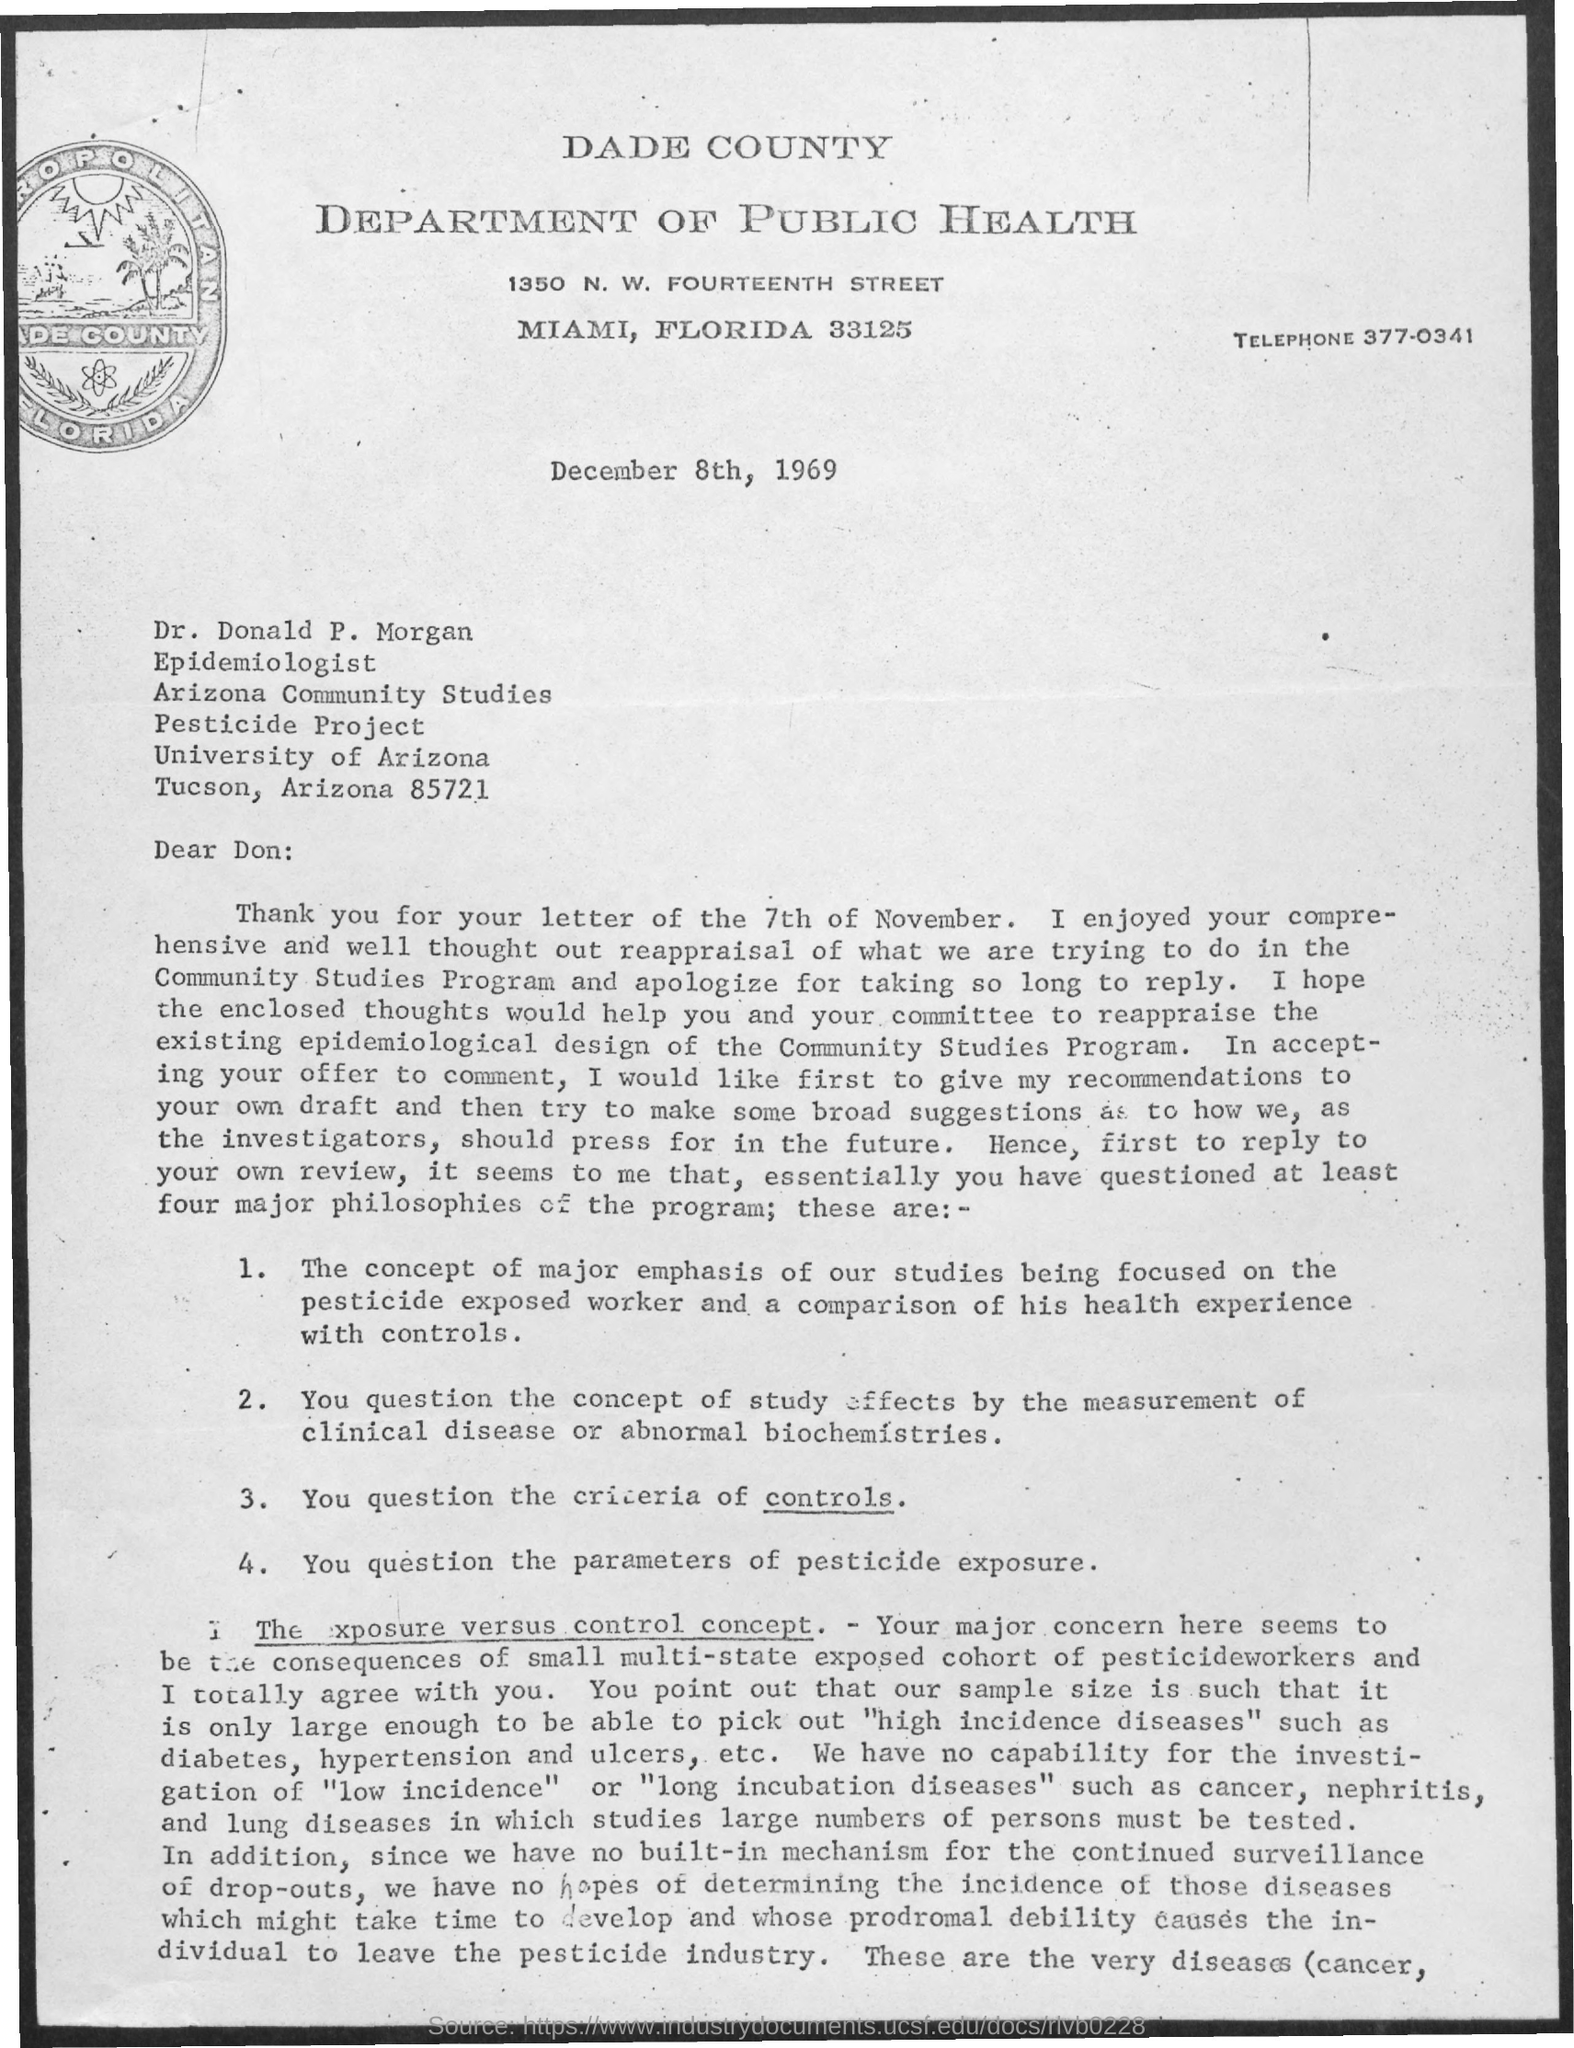Give some essential details in this illustration. The telephone is a device that is used for communication through the transmission of voice and audio signals over a wire or through the air. The date is December 8th, 1969. The letter is addressed to Dr. Donald P. Morgan. 